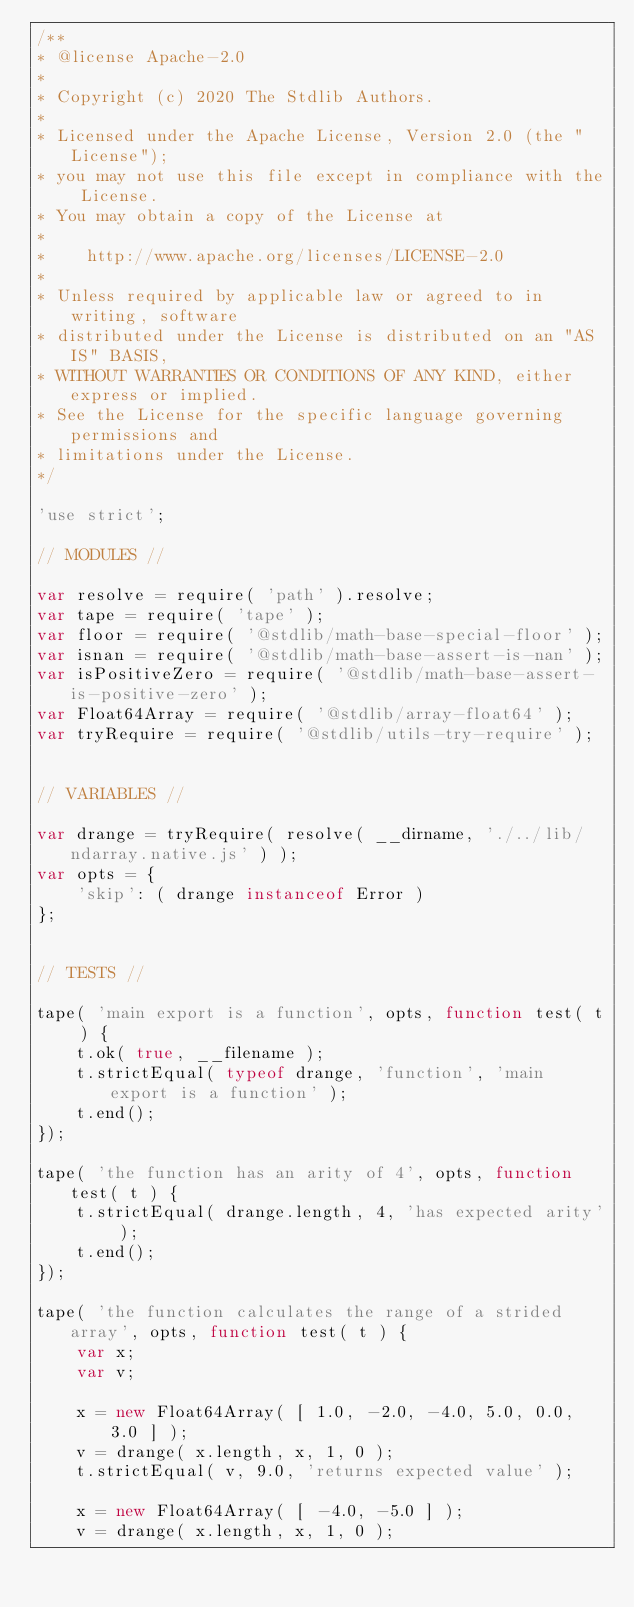Convert code to text. <code><loc_0><loc_0><loc_500><loc_500><_JavaScript_>/**
* @license Apache-2.0
*
* Copyright (c) 2020 The Stdlib Authors.
*
* Licensed under the Apache License, Version 2.0 (the "License");
* you may not use this file except in compliance with the License.
* You may obtain a copy of the License at
*
*    http://www.apache.org/licenses/LICENSE-2.0
*
* Unless required by applicable law or agreed to in writing, software
* distributed under the License is distributed on an "AS IS" BASIS,
* WITHOUT WARRANTIES OR CONDITIONS OF ANY KIND, either express or implied.
* See the License for the specific language governing permissions and
* limitations under the License.
*/

'use strict';

// MODULES //

var resolve = require( 'path' ).resolve;
var tape = require( 'tape' );
var floor = require( '@stdlib/math-base-special-floor' );
var isnan = require( '@stdlib/math-base-assert-is-nan' );
var isPositiveZero = require( '@stdlib/math-base-assert-is-positive-zero' );
var Float64Array = require( '@stdlib/array-float64' );
var tryRequire = require( '@stdlib/utils-try-require' );


// VARIABLES //

var drange = tryRequire( resolve( __dirname, './../lib/ndarray.native.js' ) );
var opts = {
	'skip': ( drange instanceof Error )
};


// TESTS //

tape( 'main export is a function', opts, function test( t ) {
	t.ok( true, __filename );
	t.strictEqual( typeof drange, 'function', 'main export is a function' );
	t.end();
});

tape( 'the function has an arity of 4', opts, function test( t ) {
	t.strictEqual( drange.length, 4, 'has expected arity' );
	t.end();
});

tape( 'the function calculates the range of a strided array', opts, function test( t ) {
	var x;
	var v;

	x = new Float64Array( [ 1.0, -2.0, -4.0, 5.0, 0.0, 3.0 ] );
	v = drange( x.length, x, 1, 0 );
	t.strictEqual( v, 9.0, 'returns expected value' );

	x = new Float64Array( [ -4.0, -5.0 ] );
	v = drange( x.length, x, 1, 0 );</code> 